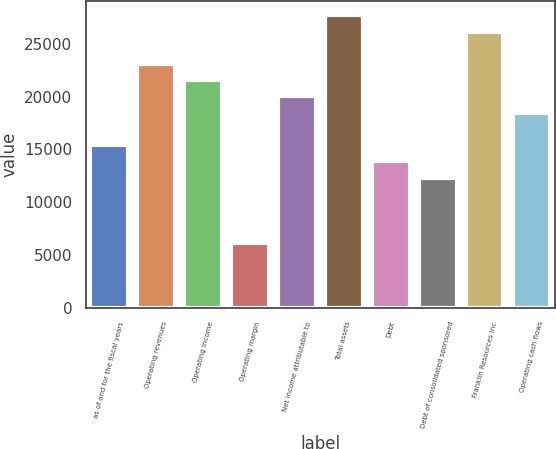Convert chart. <chart><loc_0><loc_0><loc_500><loc_500><bar_chart><fcel>as of and for the fiscal years<fcel>Operating revenues<fcel>Operating income<fcel>Operating margin<fcel>Net income attributable to<fcel>Total assets<fcel>Debt<fcel>Debt of consolidated sponsored<fcel>Franklin Resources Inc<fcel>Operating cash flows<nl><fcel>15390.3<fcel>23084.7<fcel>21545.8<fcel>6156.95<fcel>20007<fcel>27701.4<fcel>13851.4<fcel>12312.5<fcel>26162.5<fcel>18468.1<nl></chart> 